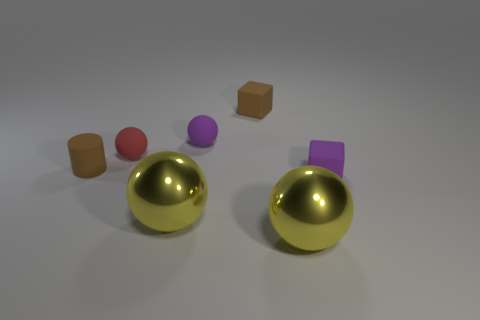Subtract 1 spheres. How many spheres are left? 3 Add 3 cylinders. How many objects exist? 10 Subtract all balls. How many objects are left? 3 Add 7 tiny red rubber objects. How many tiny red rubber objects are left? 8 Add 3 yellow objects. How many yellow objects exist? 5 Subtract 1 brown cubes. How many objects are left? 6 Subtract all tiny purple matte balls. Subtract all cylinders. How many objects are left? 5 